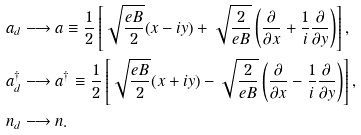Convert formula to latex. <formula><loc_0><loc_0><loc_500><loc_500>a _ { d } & \longrightarrow a \equiv \frac { 1 } { 2 } \left [ \sqrt { \frac { e B } { 2 } } ( x - i y ) + \sqrt { \frac { 2 } { e B } } \left ( \frac { \partial } { \partial x } + \frac { 1 } { i } \frac { \partial } { \partial y } \right ) \right ] , \\ a _ { d } ^ { \dag } & \longrightarrow a ^ { \dag } \equiv \frac { 1 } { 2 } \left [ \sqrt { \frac { e B } { 2 } } ( x + i y ) - \sqrt { \frac { 2 } { e B } } \left ( \frac { \partial } { \partial x } - \frac { 1 } { i } \frac { \partial } { \partial y } \right ) \right ] , \\ n _ { d } & \longrightarrow n .</formula> 